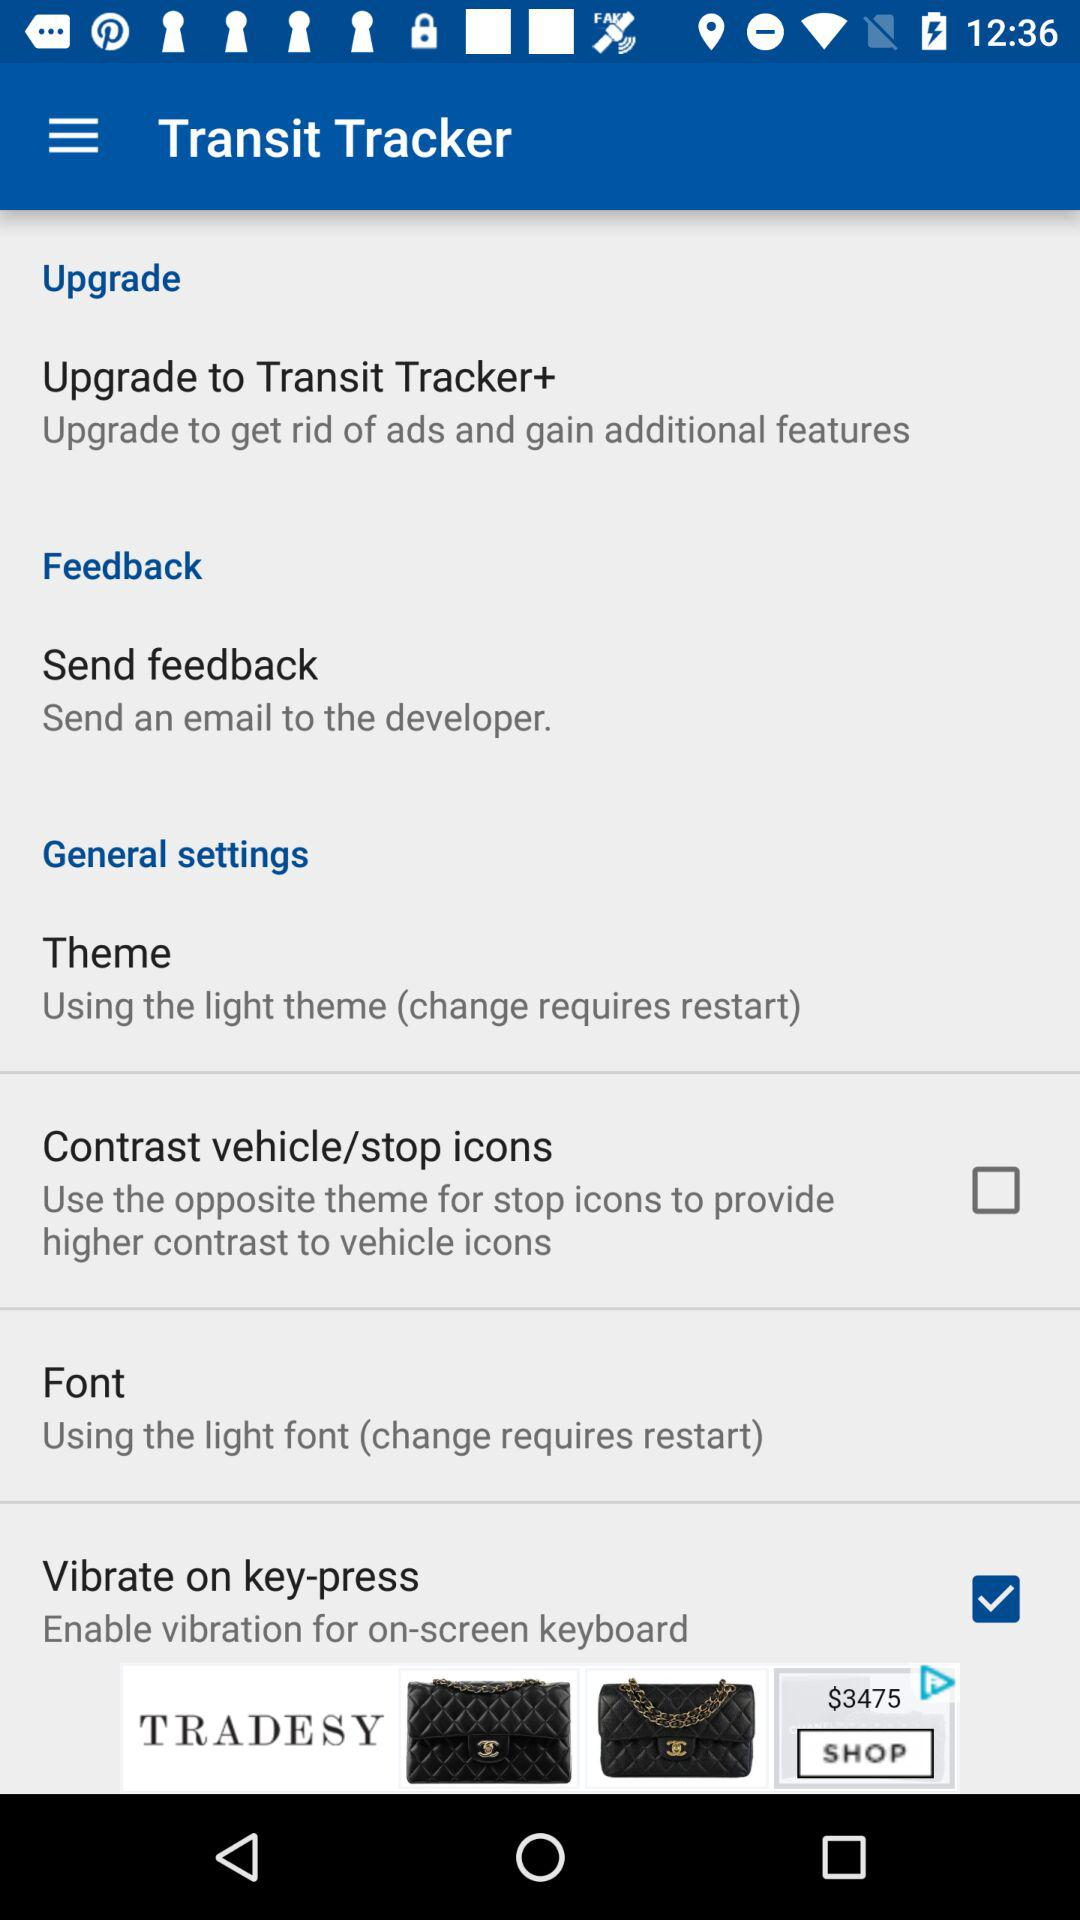How many checkboxes are in the settings menu?
Answer the question using a single word or phrase. 2 